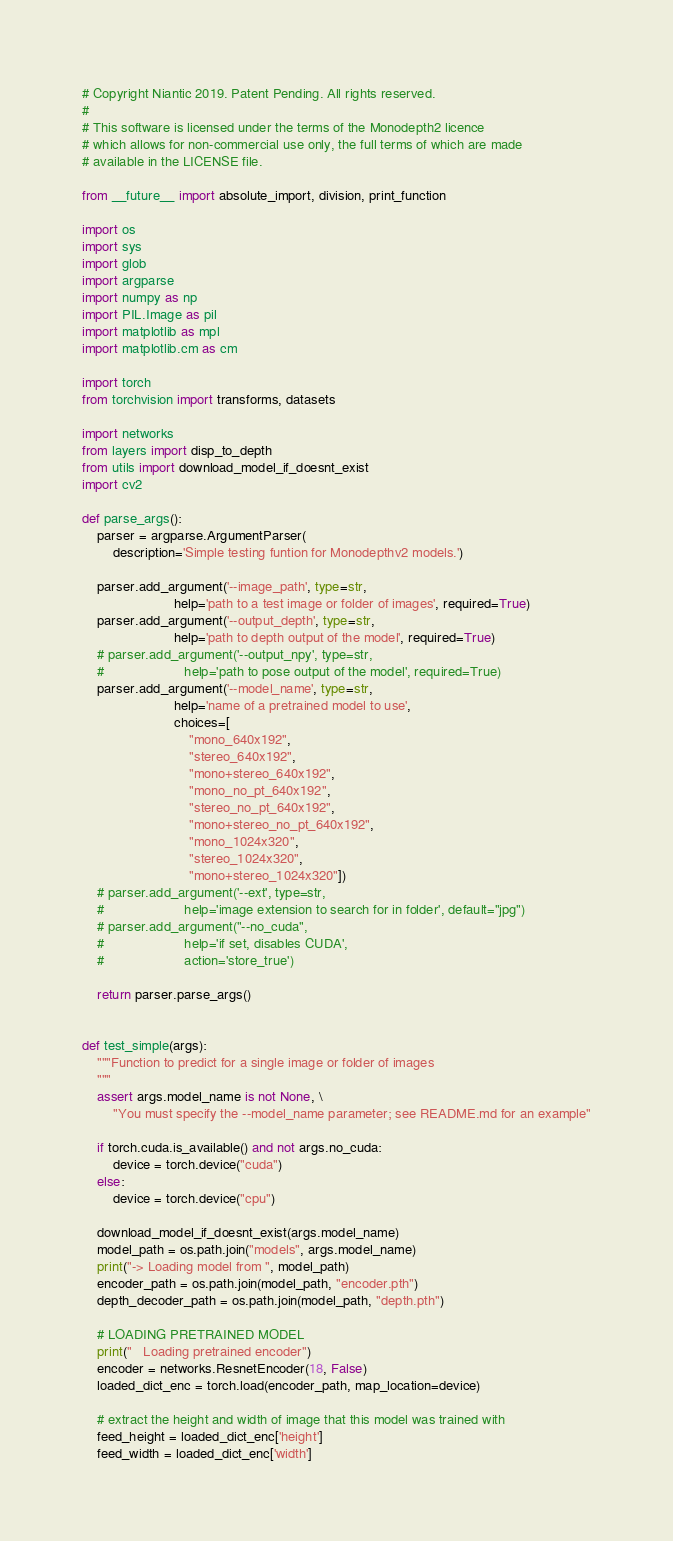Convert code to text. <code><loc_0><loc_0><loc_500><loc_500><_Python_># Copyright Niantic 2019. Patent Pending. All rights reserved.
#
# This software is licensed under the terms of the Monodepth2 licence
# which allows for non-commercial use only, the full terms of which are made
# available in the LICENSE file.

from __future__ import absolute_import, division, print_function

import os
import sys
import glob
import argparse
import numpy as np
import PIL.Image as pil
import matplotlib as mpl
import matplotlib.cm as cm

import torch
from torchvision import transforms, datasets

import networks
from layers import disp_to_depth
from utils import download_model_if_doesnt_exist
import cv2

def parse_args():
    parser = argparse.ArgumentParser(
        description='Simple testing funtion for Monodepthv2 models.')

    parser.add_argument('--image_path', type=str,
                        help='path to a test image or folder of images', required=True)
    parser.add_argument('--output_depth', type=str,
                        help='path to depth output of the model', required=True)
    # parser.add_argument('--output_npy', type=str,
    #                     help='path to pose output of the model', required=True)
    parser.add_argument('--model_name', type=str,
                        help='name of a pretrained model to use',
                        choices=[
                            "mono_640x192",
                            "stereo_640x192",
                            "mono+stereo_640x192",
                            "mono_no_pt_640x192",
                            "stereo_no_pt_640x192",
                            "mono+stereo_no_pt_640x192",
                            "mono_1024x320",
                            "stereo_1024x320",
                            "mono+stereo_1024x320"])
    # parser.add_argument('--ext', type=str,
    #                     help='image extension to search for in folder', default="jpg")
    # parser.add_argument("--no_cuda",
    #                     help='if set, disables CUDA',
    #                     action='store_true')

    return parser.parse_args()


def test_simple(args):
    """Function to predict for a single image or folder of images
    """
    assert args.model_name is not None, \
        "You must specify the --model_name parameter; see README.md for an example"

    if torch.cuda.is_available() and not args.no_cuda:
        device = torch.device("cuda")
    else:
        device = torch.device("cpu")

    download_model_if_doesnt_exist(args.model_name)
    model_path = os.path.join("models", args.model_name)
    print("-> Loading model from ", model_path)
    encoder_path = os.path.join(model_path, "encoder.pth")
    depth_decoder_path = os.path.join(model_path, "depth.pth")

    # LOADING PRETRAINED MODEL
    print("   Loading pretrained encoder")
    encoder = networks.ResnetEncoder(18, False)
    loaded_dict_enc = torch.load(encoder_path, map_location=device)

    # extract the height and width of image that this model was trained with
    feed_height = loaded_dict_enc['height']
    feed_width = loaded_dict_enc['width']</code> 